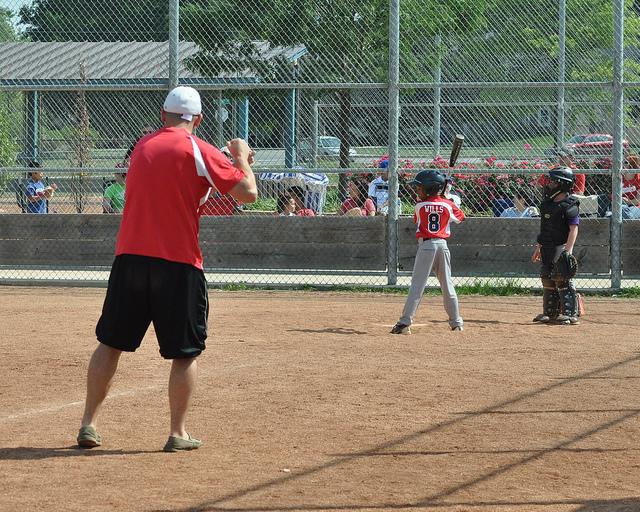Is the batter a professional?
Give a very brief answer. No. What color is the fence?
Keep it brief. Silver. Is the batter left handed or right handed?
Keep it brief. Right. What sport are they playing?
Quick response, please. Baseball. What are they holding?
Be succinct. Bat. What is the number on the man's shorts?
Quick response, please. 8. What color are the man's short?
Short answer required. Black. What sport is this?
Give a very brief answer. Baseball. Is anyone wearing a purple shirt?
Concise answer only. No. Is the batter batting right or left handed?
Write a very short answer. Right. What objects are red?
Give a very brief answer. Shirts. Is he at home plate?
Short answer required. Yes. What sport is the boy playing?
Be succinct. Baseball. 